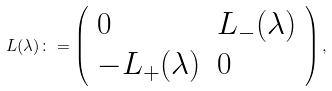<formula> <loc_0><loc_0><loc_500><loc_500>L ( \lambda ) \colon = \left ( \begin{array} { l l l } 0 & L _ { - } ( \lambda ) \\ - L _ { + } ( \lambda ) & 0 \end{array} \right ) ,</formula> 